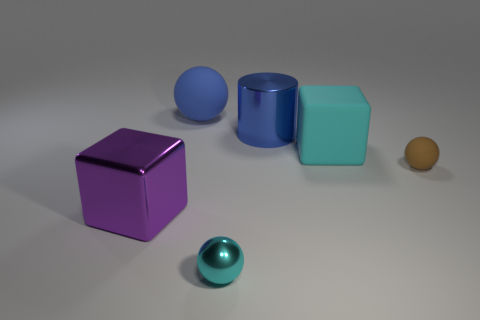Subtract all small balls. How many balls are left? 1 Subtract all cubes. How many objects are left? 4 Add 4 big rubber objects. How many objects exist? 10 Subtract all blue balls. How many balls are left? 2 Subtract all gray balls. Subtract all blue cubes. How many balls are left? 3 Subtract all cylinders. Subtract all large blue shiny objects. How many objects are left? 4 Add 4 big metal things. How many big metal things are left? 6 Add 2 big green shiny blocks. How many big green shiny blocks exist? 2 Subtract 0 yellow blocks. How many objects are left? 6 Subtract 1 cylinders. How many cylinders are left? 0 